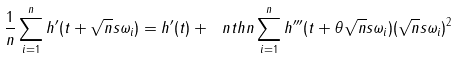Convert formula to latex. <formula><loc_0><loc_0><loc_500><loc_500>\frac { 1 } { n } \sum _ { i = 1 } ^ { n } h ^ { \prime } ( t + \sqrt { n } s \omega _ { i } ) = h ^ { \prime } ( t ) + \ n t h n \sum _ { i = 1 } ^ { n } h ^ { \prime \prime \prime } ( t + \theta \sqrt { n } s \omega _ { i } ) ( \sqrt { n } s \omega _ { i } ) ^ { 2 }</formula> 